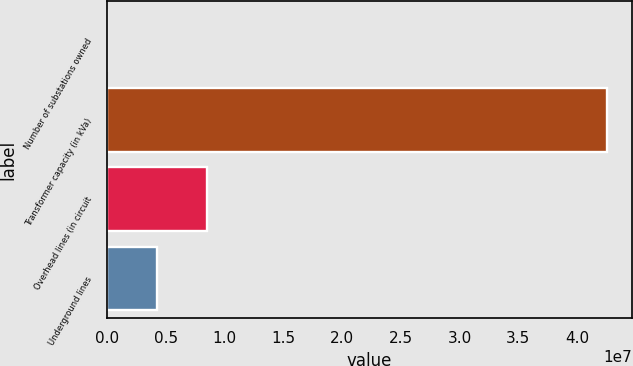<chart> <loc_0><loc_0><loc_500><loc_500><bar_chart><fcel>Number of substations owned<fcel>Transformer capacity (in kVa)<fcel>Overhead lines (in circuit<fcel>Underground lines<nl><fcel>510<fcel>4.2516e+07<fcel>8.50361e+06<fcel>4.25206e+06<nl></chart> 